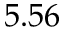<formula> <loc_0><loc_0><loc_500><loc_500>5 . 5 6</formula> 